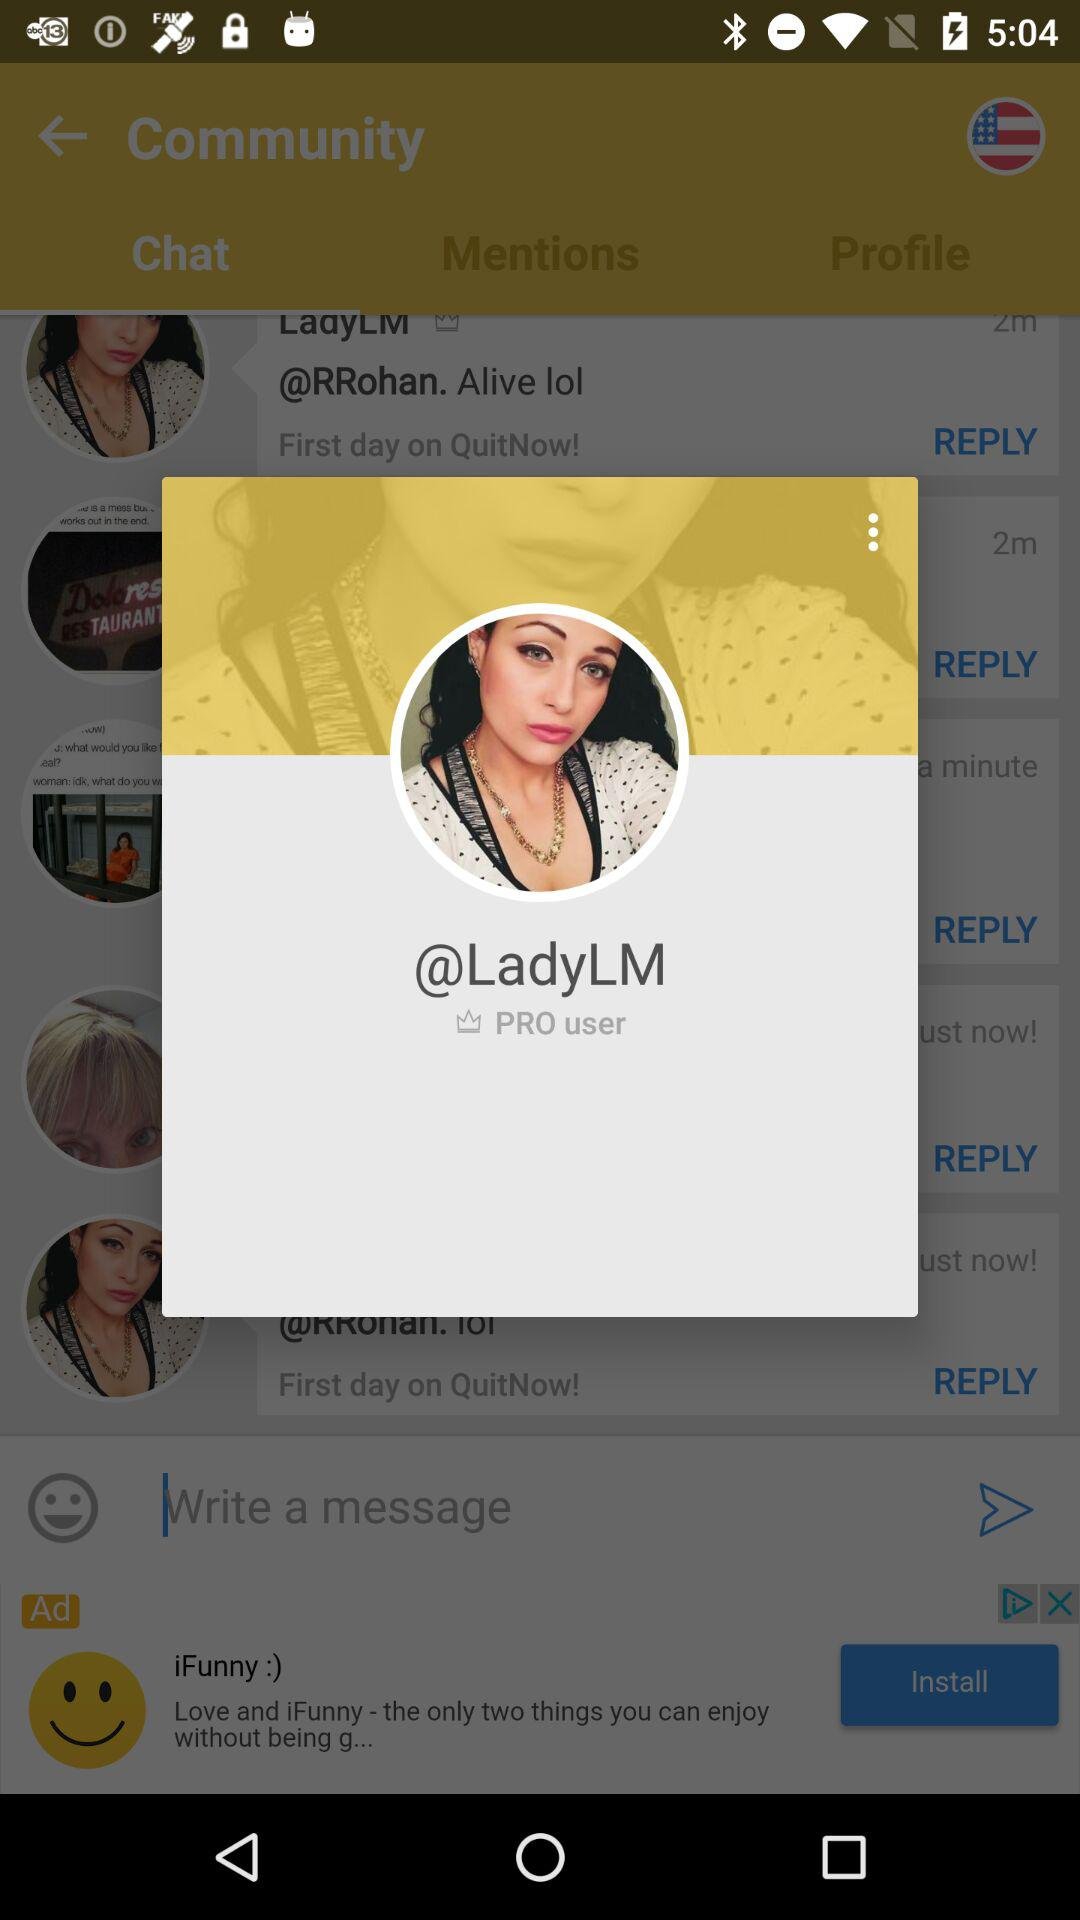What tag has been assigned to the user? The tag that has been assigned to the user is "PRO user". 